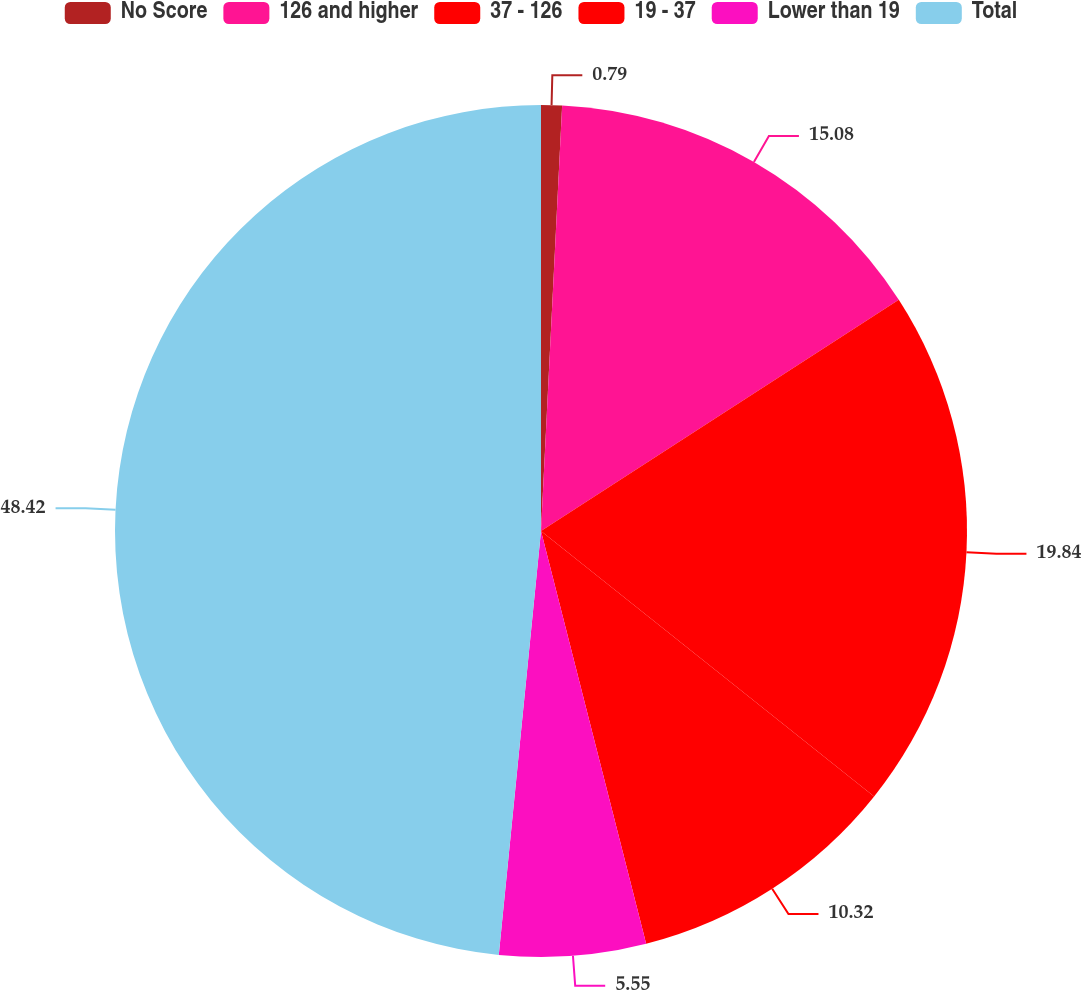Convert chart to OTSL. <chart><loc_0><loc_0><loc_500><loc_500><pie_chart><fcel>No Score<fcel>126 and higher<fcel>37 - 126<fcel>19 - 37<fcel>Lower than 19<fcel>Total<nl><fcel>0.79%<fcel>15.08%<fcel>19.84%<fcel>10.32%<fcel>5.55%<fcel>48.42%<nl></chart> 